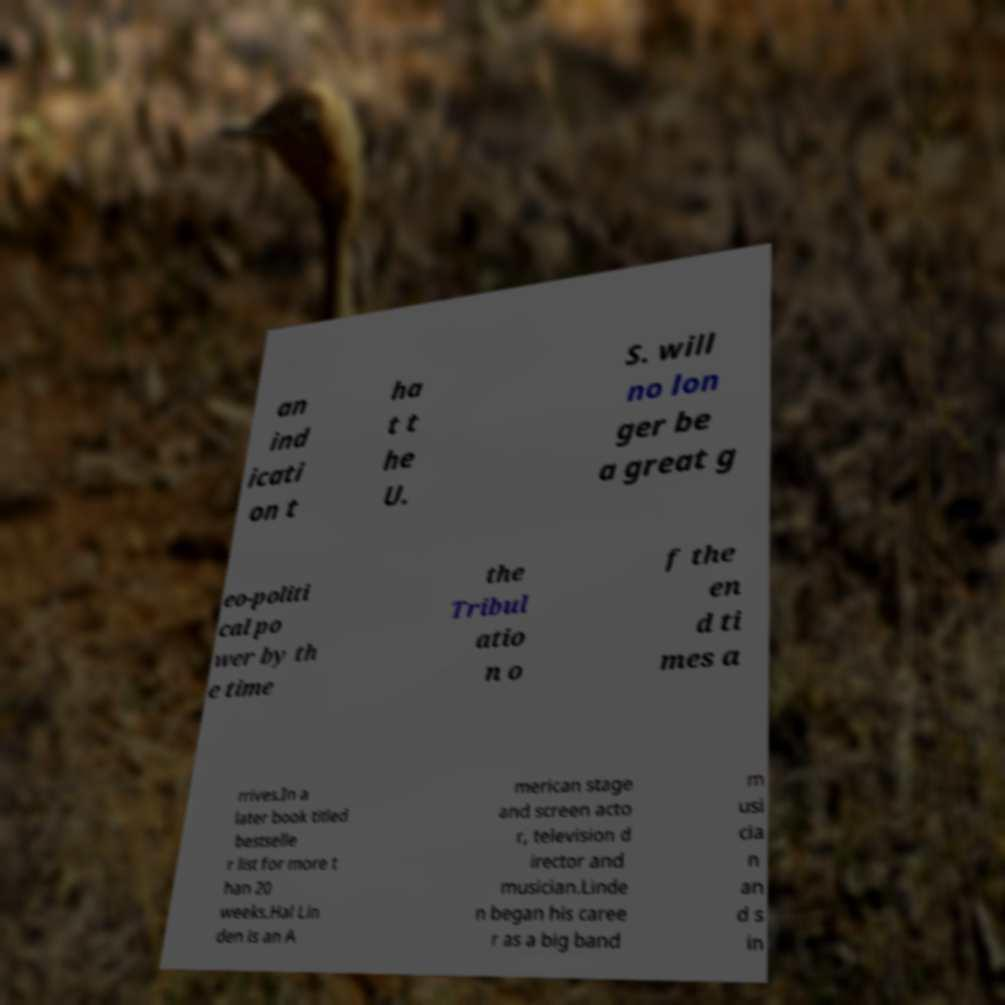There's text embedded in this image that I need extracted. Can you transcribe it verbatim? an ind icati on t ha t t he U. S. will no lon ger be a great g eo-politi cal po wer by th e time the Tribul atio n o f the en d ti mes a rrives.In a later book titled bestselle r list for more t han 20 weeks.Hal Lin den is an A merican stage and screen acto r, television d irector and musician.Linde n began his caree r as a big band m usi cia n an d s in 